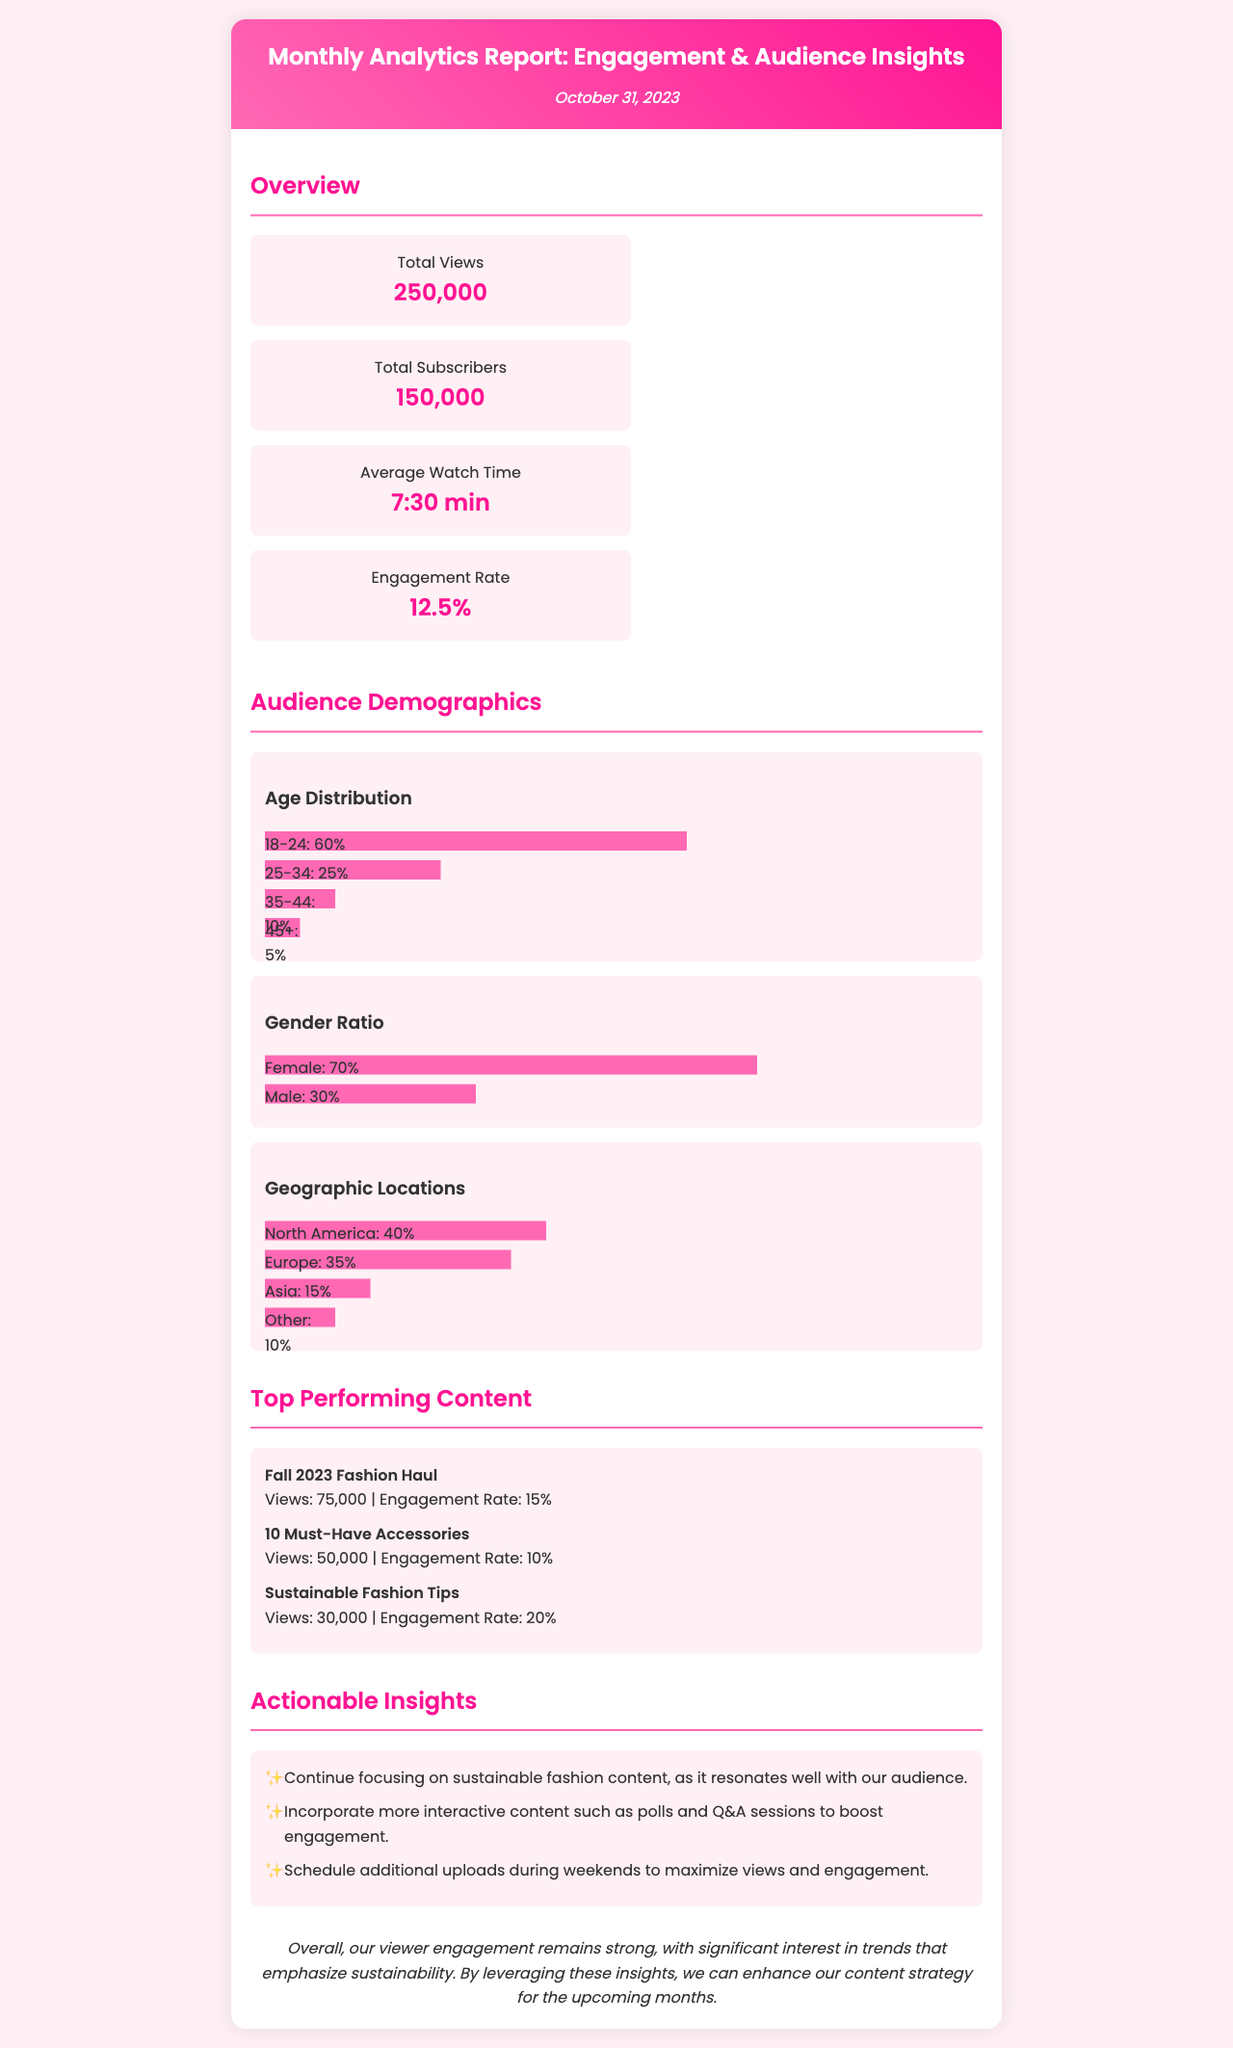What is the total number of views? The total number of views is provided in the overview section of the document, which states the total views as 250,000.
Answer: 250,000 What is the average watch time? The average watch time is mentioned in the overview section as 7 minutes and 30 seconds.
Answer: 7:30 min What percentage of the audience is female? The gender ratio chart specifies that 70% of the audience is female.
Answer: 70% Which video had the highest engagement rate? The top-performing content section shows that the "Sustainable Fashion Tips" video has the highest engagement rate at 20%.
Answer: Sustainable Fashion Tips What age group constitutes the largest portion of the audience? The age distribution chart indicates that the 18-24 age group makes up 60% of the audience.
Answer: 18-24 How many insights are provided in the actionable insights section? The actionable insights section lists three specific insights, which can be counted directly.
Answer: 3 What is the total number of subscribers? The total number of subscribers is stated in the overview section as 150,000.
Answer: 150,000 What geographic location has the highest viewer percentage? The geographic locations chart shows that North America has the highest percentage of viewers at 40%.
Answer: North America What themes should be focused on in future content? The actionable insights suggest focusing on sustainable fashion content as it resonates well with the audience.
Answer: Sustainable fashion 